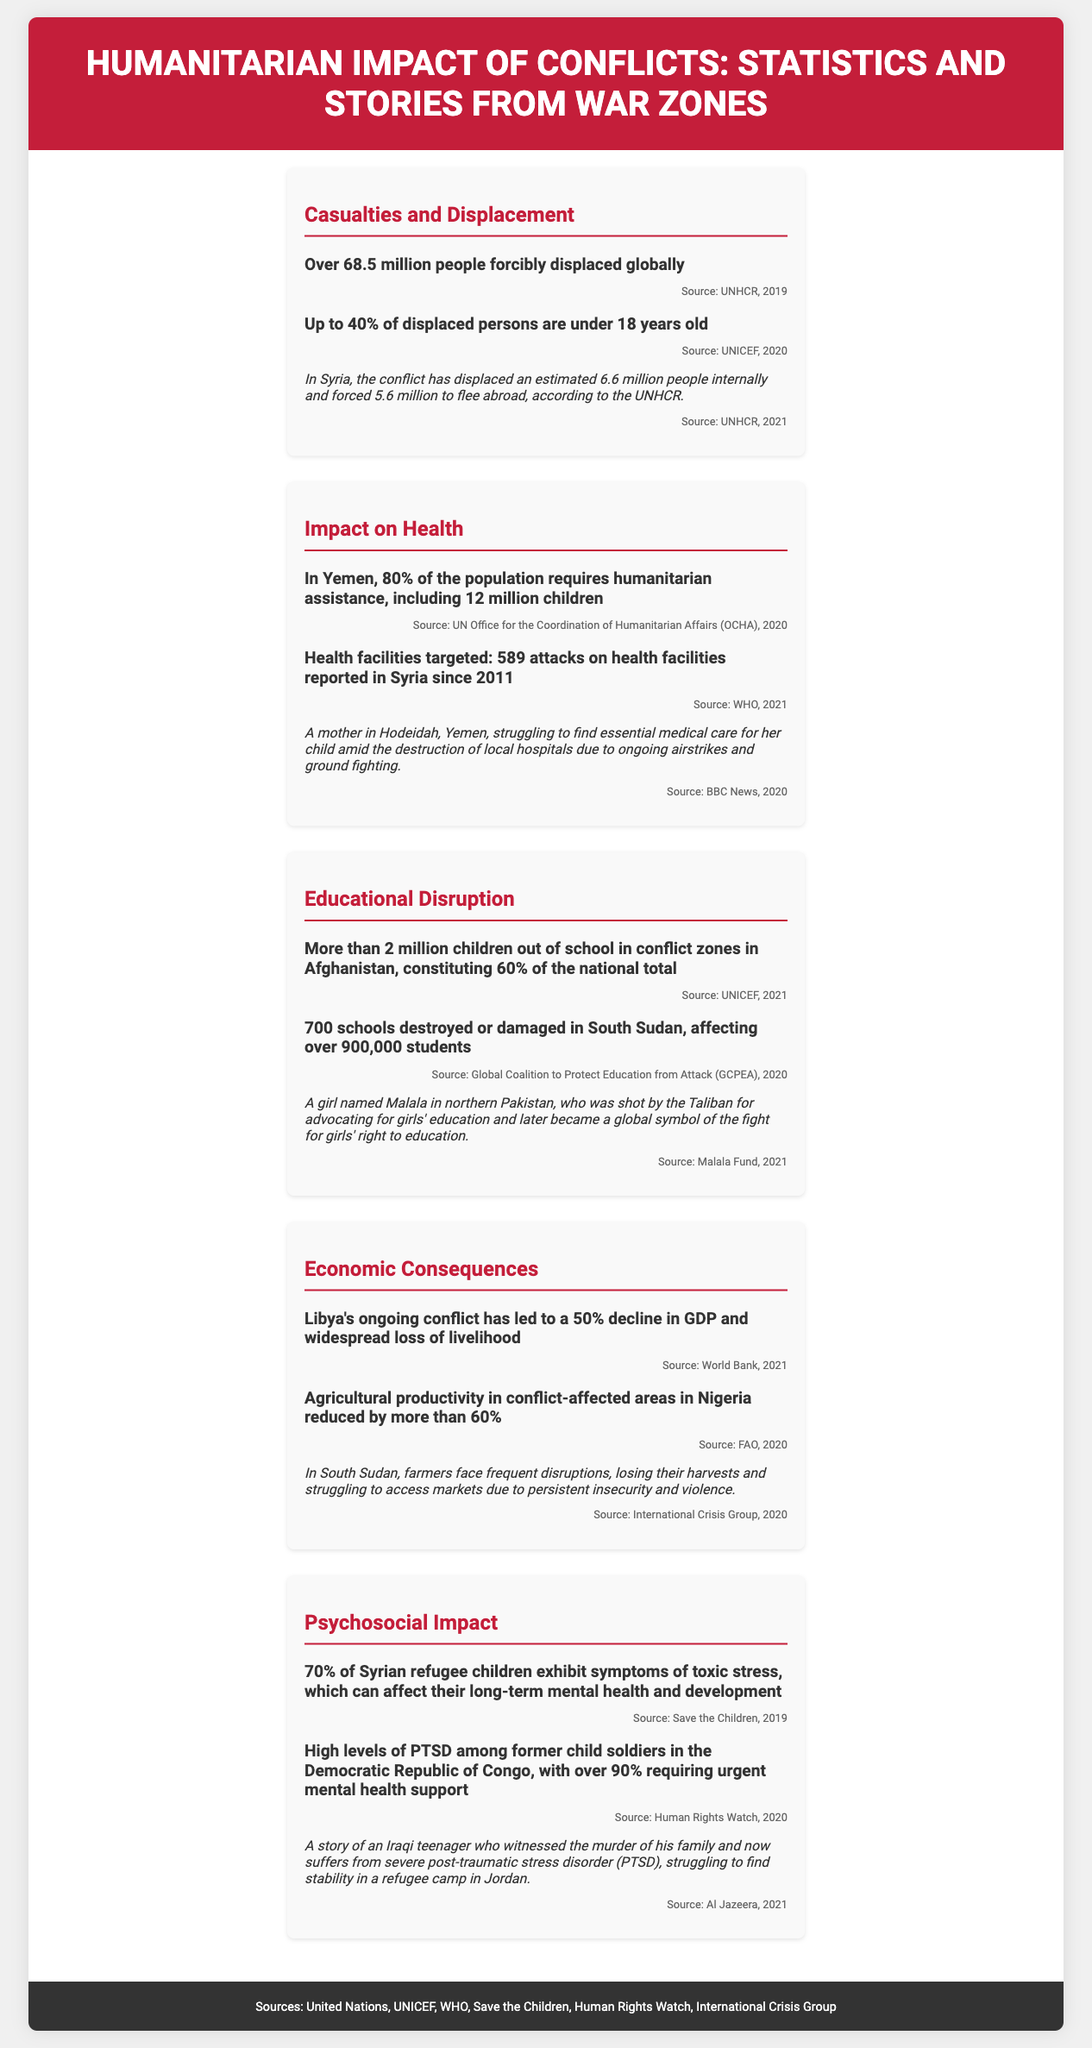what is the total number of forcibly displaced people globally? The document states that over 68.5 million people are forcibly displaced globally.
Answer: over 68.5 million what percentage of displaced persons are under 18 years old? According to the document, up to 40% of displaced persons are under 18 years old.
Answer: 40% how many children require humanitarian assistance in Yemen? The document mentions that 12 million children in Yemen require humanitarian assistance.
Answer: 12 million how many schools were destroyed or damaged in South Sudan? The document indicates that 700 schools were destroyed or damaged in South Sudan.
Answer: 700 what is the GDP decline percentage in Libya due to ongoing conflict? The document states that Libya's ongoing conflict has led to a 50% decline in GDP.
Answer: 50% how many attacks on health facilities were reported in Syria since 2011? The document notes that there were 589 attacks on health facilities reported in Syria since 2011.
Answer: 589 what is the psychosocial symptom percentage among Syrian refugee children? According to the document, 70% of Syrian refugee children exhibit symptoms of toxic stress.
Answer: 70% which girl became a symbol for the fight for girls' right to education? The document refers to Malala as a girl who became a global symbol for the fight for girls' right to education.
Answer: Malala what is a critical need for former child soldiers in the Democratic Republic of Congo? The document states that over 90% of former child soldiers require urgent mental health support.
Answer: urgent mental health support 